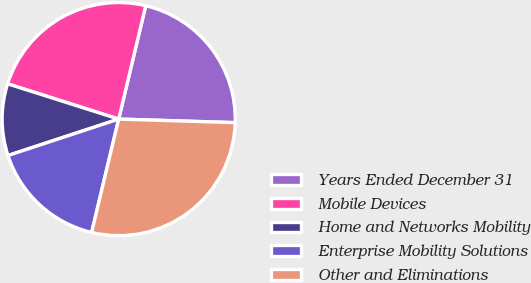Convert chart to OTSL. <chart><loc_0><loc_0><loc_500><loc_500><pie_chart><fcel>Years Ended December 31<fcel>Mobile Devices<fcel>Home and Networks Mobility<fcel>Enterprise Mobility Solutions<fcel>Other and Eliminations<nl><fcel>21.76%<fcel>23.83%<fcel>9.95%<fcel>16.21%<fcel>28.24%<nl></chart> 